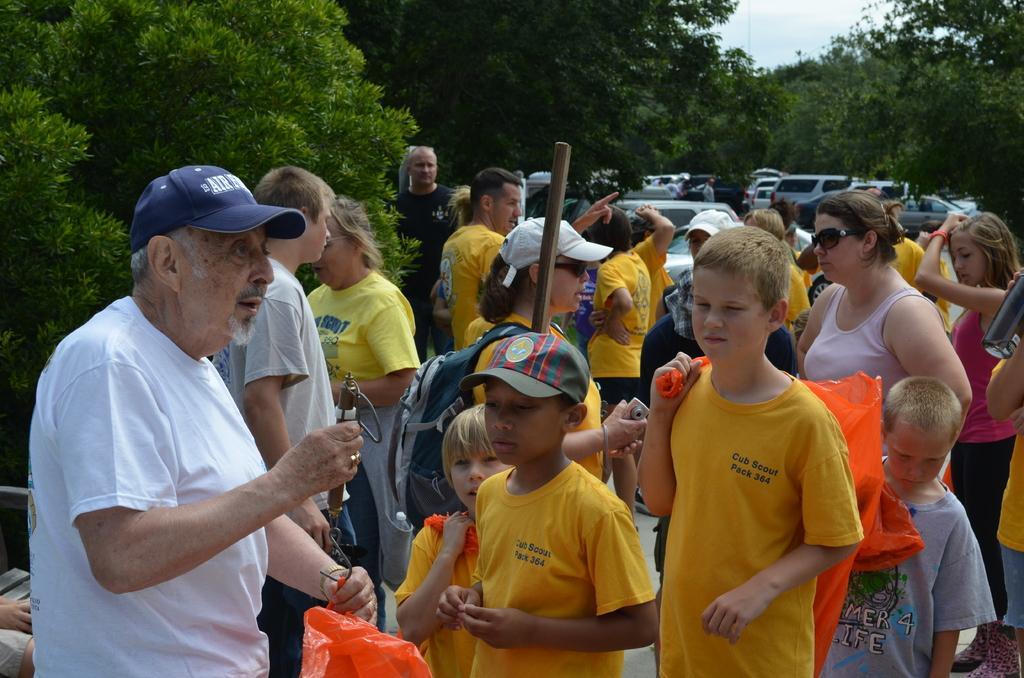Please provide a concise description of this image. In this image I can see there are group of persons and some of them are holding the sticks and caring the carry bags and I can see the vehicle in the middle and the sky and trees visible at the top. 